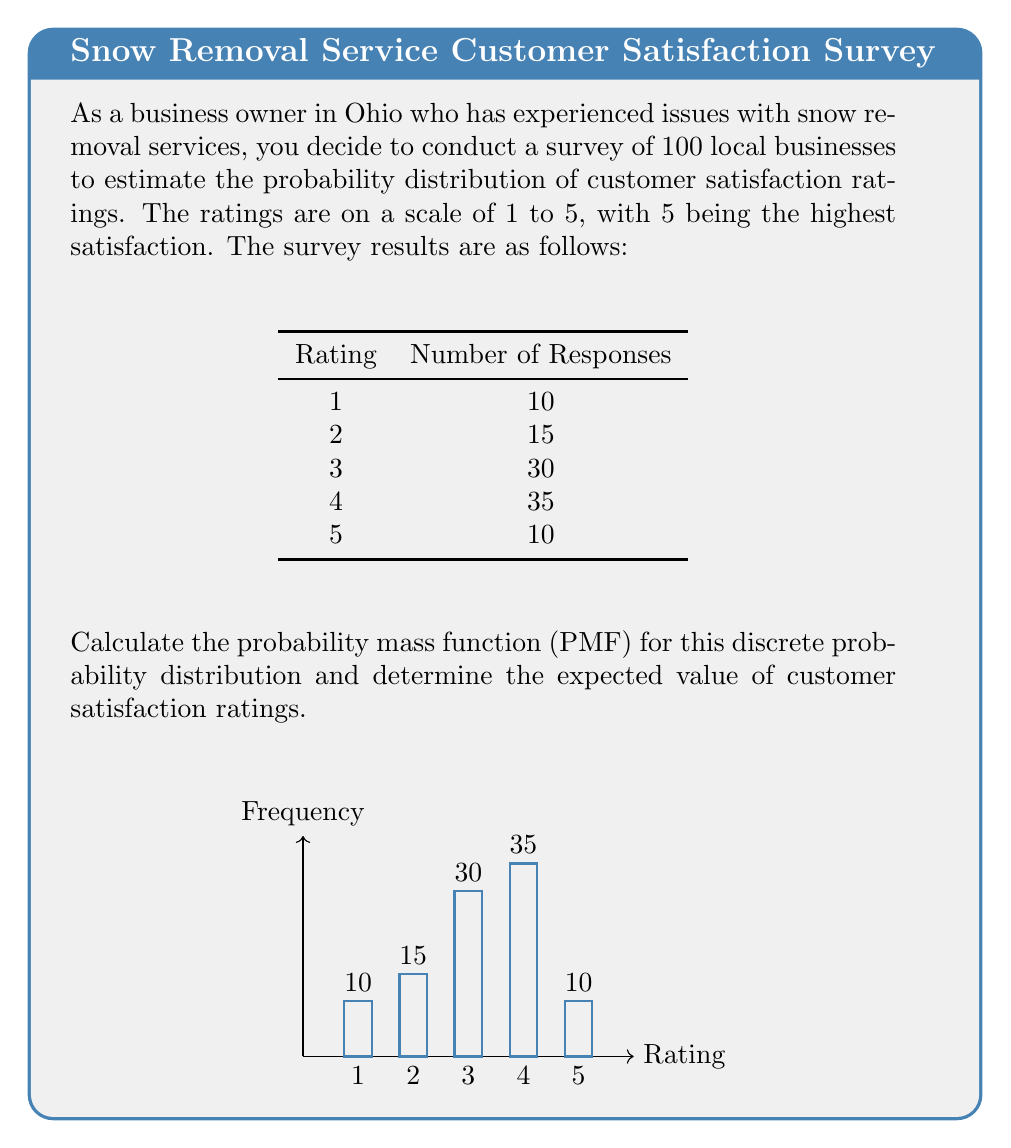Teach me how to tackle this problem. To solve this problem, we'll follow these steps:

1) Calculate the probability mass function (PMF):
   The PMF gives the probability of each possible outcome. To calculate it, we divide the number of responses for each rating by the total number of responses.

   $P(X = x) = \frac{\text{Number of responses for rating x}}{\text{Total number of responses}}$

   $P(X = 1) = \frac{10}{100} = 0.10$
   $P(X = 2) = \frac{15}{100} = 0.15$
   $P(X = 3) = \frac{30}{100} = 0.30$
   $P(X = 4) = \frac{35}{100} = 0.35$
   $P(X = 5) = \frac{10}{100} = 0.10$

2) Calculate the expected value:
   The expected value is the sum of each possible outcome multiplied by its probability.

   $E(X) = \sum_{x=1}^{5} x \cdot P(X = x)$

   $E(X) = 1 \cdot 0.10 + 2 \cdot 0.15 + 3 \cdot 0.30 + 4 \cdot 0.35 + 5 \cdot 0.10$
   
   $E(X) = 0.10 + 0.30 + 0.90 + 1.40 + 0.50 = 3.20$

Therefore, the PMF is {0.10, 0.15, 0.30, 0.35, 0.10} for ratings 1 through 5 respectively, and the expected value of customer satisfaction ratings is 3.20.
Answer: PMF: {0.10, 0.15, 0.30, 0.35, 0.10}; Expected value: 3.20 